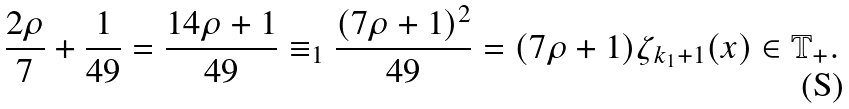Convert formula to latex. <formula><loc_0><loc_0><loc_500><loc_500>\frac { 2 \rho } { 7 } + \frac { 1 } { 4 9 } = \frac { 1 4 \rho + 1 } { 4 9 } \equiv _ { 1 } \frac { ( 7 \rho + 1 ) ^ { 2 } } { 4 9 } = ( 7 \rho + 1 ) \zeta _ { k _ { 1 } + 1 } ( x ) \in \mathbb { T } _ { + } .</formula> 